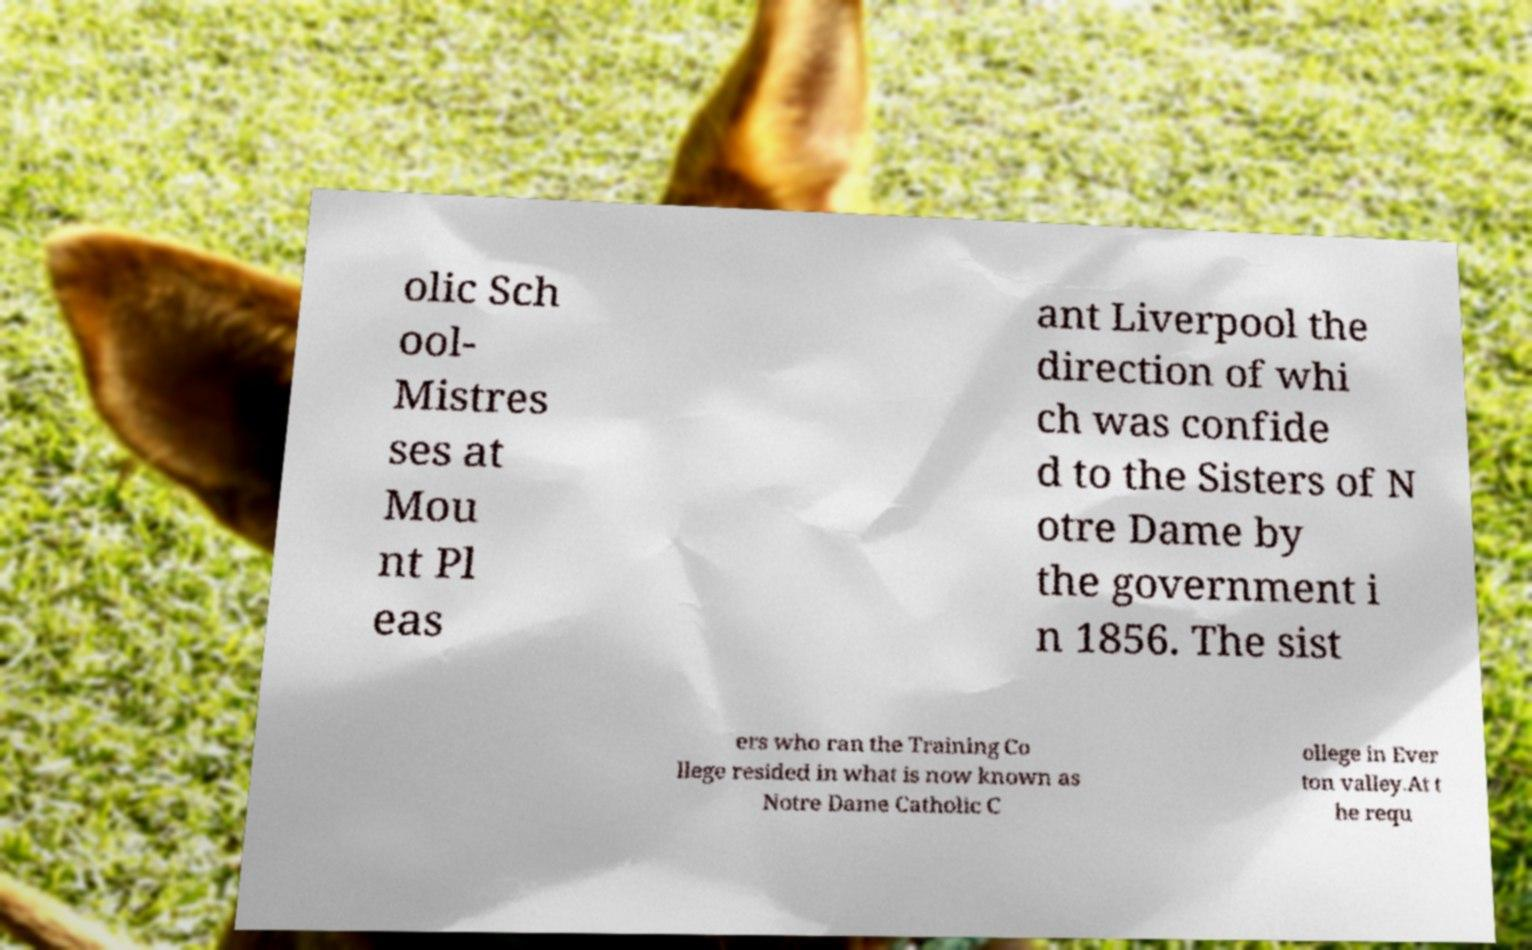What messages or text are displayed in this image? I need them in a readable, typed format. olic Sch ool- Mistres ses at Mou nt Pl eas ant Liverpool the direction of whi ch was confide d to the Sisters of N otre Dame by the government i n 1856. The sist ers who ran the Training Co llege resided in what is now known as Notre Dame Catholic C ollege in Ever ton valley.At t he requ 